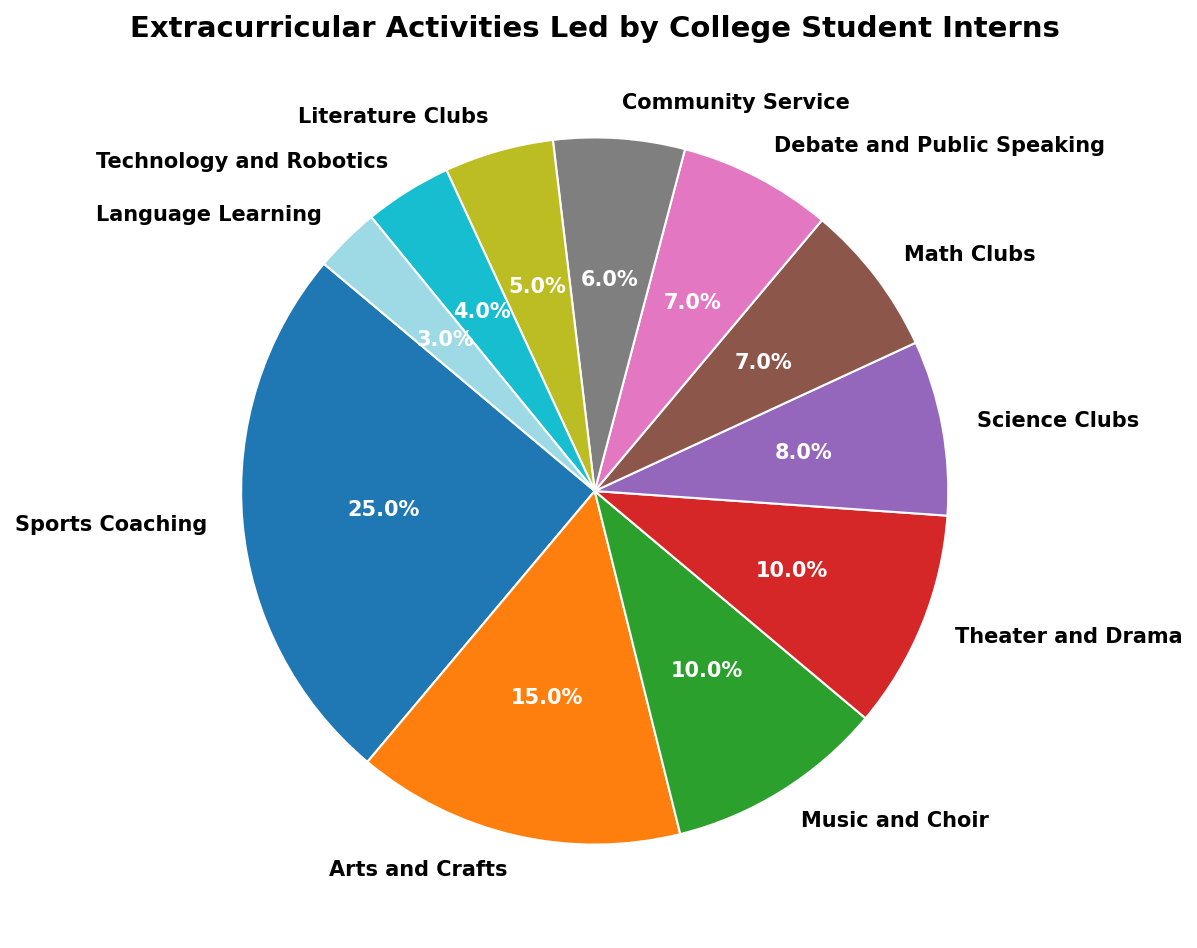what is the total percentage of all academic-related activities combined? The academic-related activities are Science Clubs, Math Clubs, Literature Clubs, and Technology and Robotics. Add their percentages: 8 (Science Clubs) + 7 (Math Clubs) + 5 (Literature Clubs) + 4 (Technology and Robotics) = 24%. Therefore, the total percentage of academic-related activities is 24%
Answer: 24% Which extracurricular activity has the highest representation? Looking at the pie chart, the activity with the largest wedge representing 25% is Sports Coaching
Answer: Sports Coaching What is the difference in percentage between Sports Coaching and Music and Choir? Sports Coaching has 25%, while Music and Choir has 10%. The difference is calculated as 25% - 10% = 15%
Answer: 15% Are there more arts-related or language-related activities in terms of percentage? Arts-related activities include Arts and Crafts (15%) and Theater and Drama (10%), totaling 25%. Language Learning is 3%. 25% (arts-related) is greater than 3% (language-related)
Answer: Arts-related How many activities have a percentage that is less than 7%? The activities with less than 7% are Community Service (6%), Literature Clubs (5%), Technology and Robotics (4%), and Language Learning (3%). There are 4 such activities
Answer: 4 Which two activities have the same percentage representation? The pie chart shows that Math Clubs and Debate and Public Speaking both have a percentage of 7%
Answer: Math Clubs and Debate and Public Speaking What is the average percentage of the categories Music and Choir, Theater and Drama, and Language Learning? The percentages are Music and Choir (10%), Theater and Drama (10%), and Language Learning (3%). The average is calculated as (10 + 10 + 3) / 3 = 23 / 3 = 7.67%
Answer: 7.67% Which activity has the smallest percentage representation? According to the pie chart, Language Learning has the smallest representation at 3%
Answer: Language Learning What is the combined percentage of Theater and Drama and Community Service? The percentage for Theater and Drama is 10% and for Community Service is 6%. Adding these gives 10% + 6% = 16%
Answer: 16% Is the percentage of Science Clubs higher than Literature Clubs and Technology and Robotics combined? Science Clubs has 8%. Literature Clubs (5%) combined with Technology and Robotics (4%) is 5% + 4% = 9%. Therefore, 8% (Science Clubs) is less than 9% (Literature Clubs + Technology and Robotics)
Answer: No 